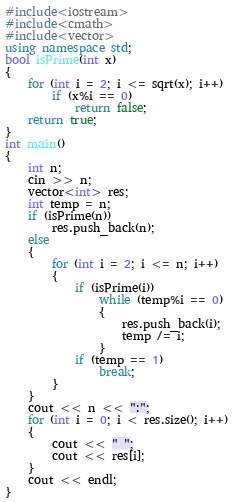Convert code to text. <code><loc_0><loc_0><loc_500><loc_500><_C++_>#include<iostream>
#include<cmath>
#include<vector>
using namespace std;
bool isPrime(int x)
{
	for (int i = 2; i <= sqrt(x); i++)
		if (x%i == 0)
			return false;
	return true;
}
int main()
{
	int n;
	cin >> n;
	vector<int> res;
	int temp = n;
	if (isPrime(n))
		res.push_back(n);
	else
	{
		for (int i = 2; i <= n; i++)
		{
			if (isPrime(i))
				while (temp%i == 0)
				{
					res.push_back(i);
					temp /= i;
				}
			if (temp == 1)
				break;
		}
	}
	cout << n << ":";
	for (int i = 0; i < res.size(); i++)
	{
		cout << " ";
		cout << res[i];
	}
	cout << endl;
}
</code> 